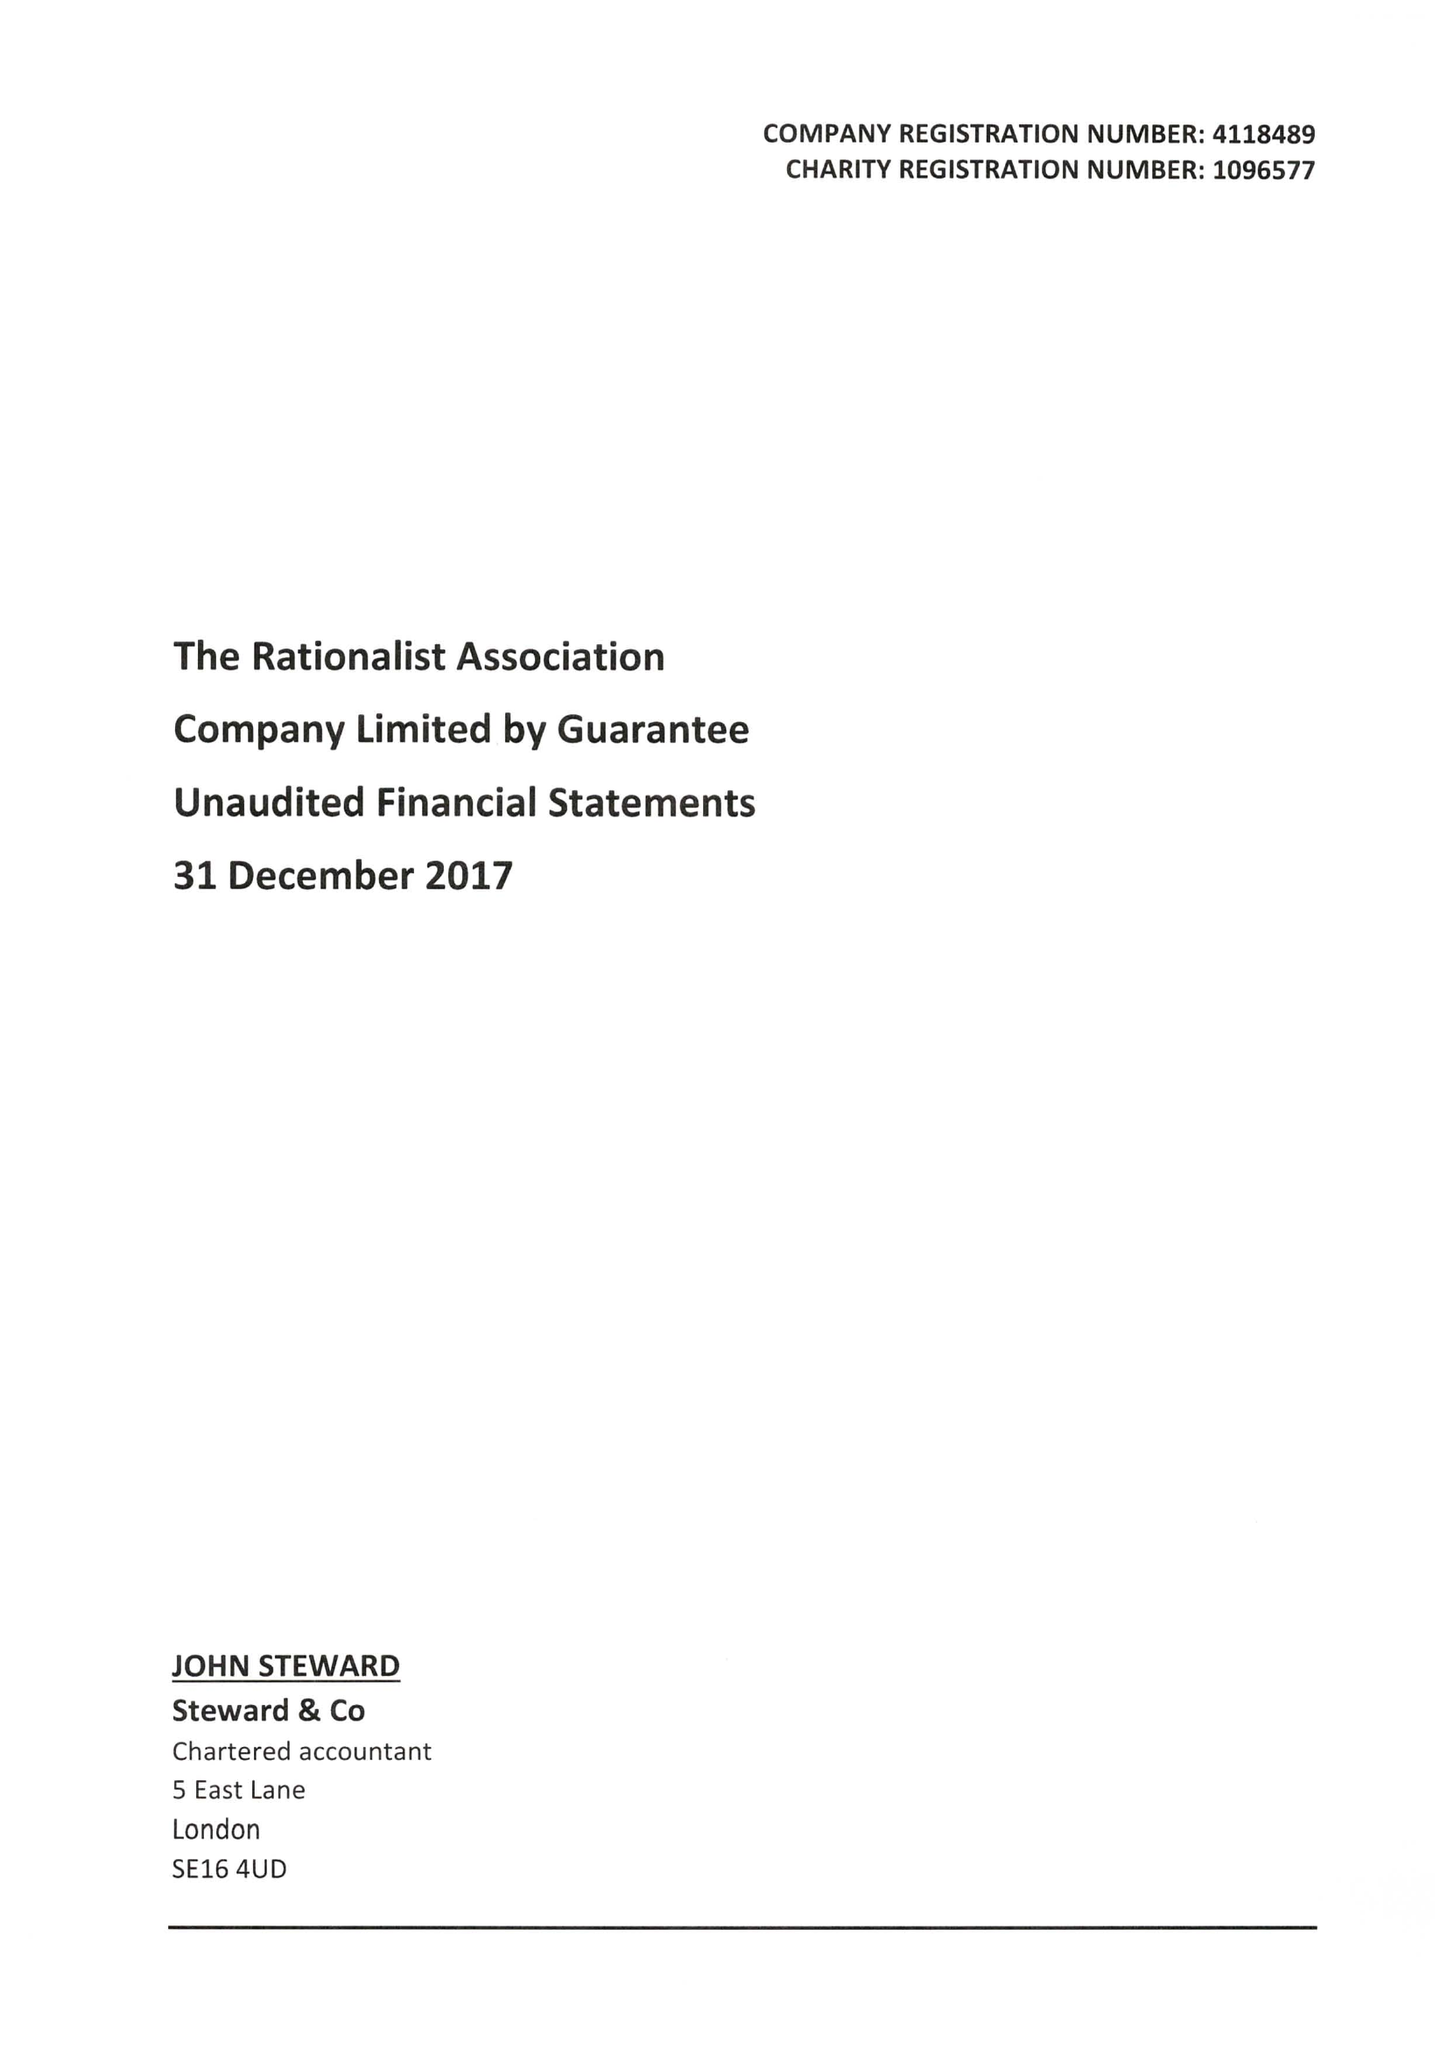What is the value for the spending_annually_in_british_pounds?
Answer the question using a single word or phrase. 173888.00 